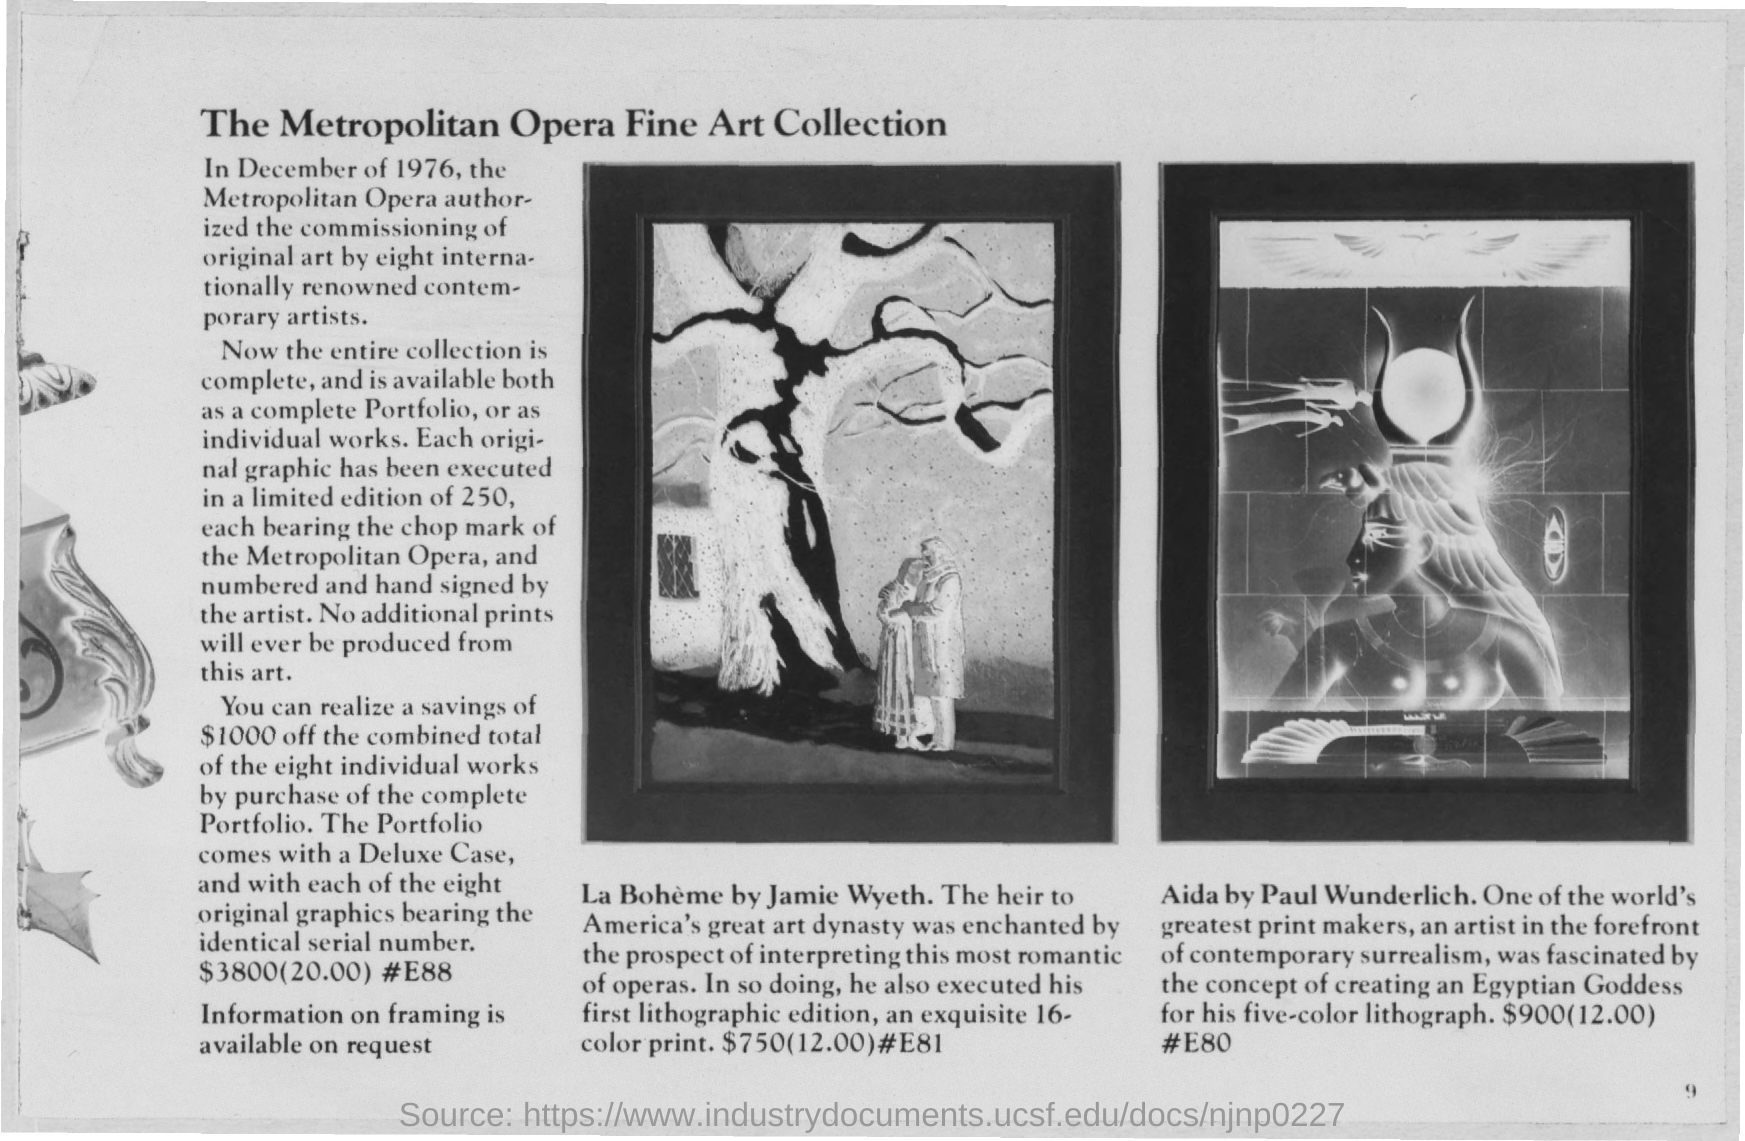Highlight a few significant elements in this photo. La Boheme by Jamie Wyeth has a price of $750. The price of Paul Wunderlich's Aida is $900. 